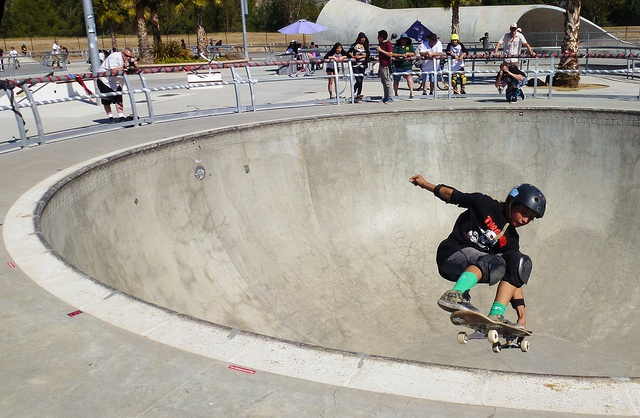Describe the objects in this image and their specific colors. I can see people in black, gray, darkgray, and tan tones, people in black, darkgray, gray, and tan tones, people in black, lightgray, gray, and darkgray tones, skateboard in black, gray, and darkgray tones, and people in black, darkgray, gray, and maroon tones in this image. 